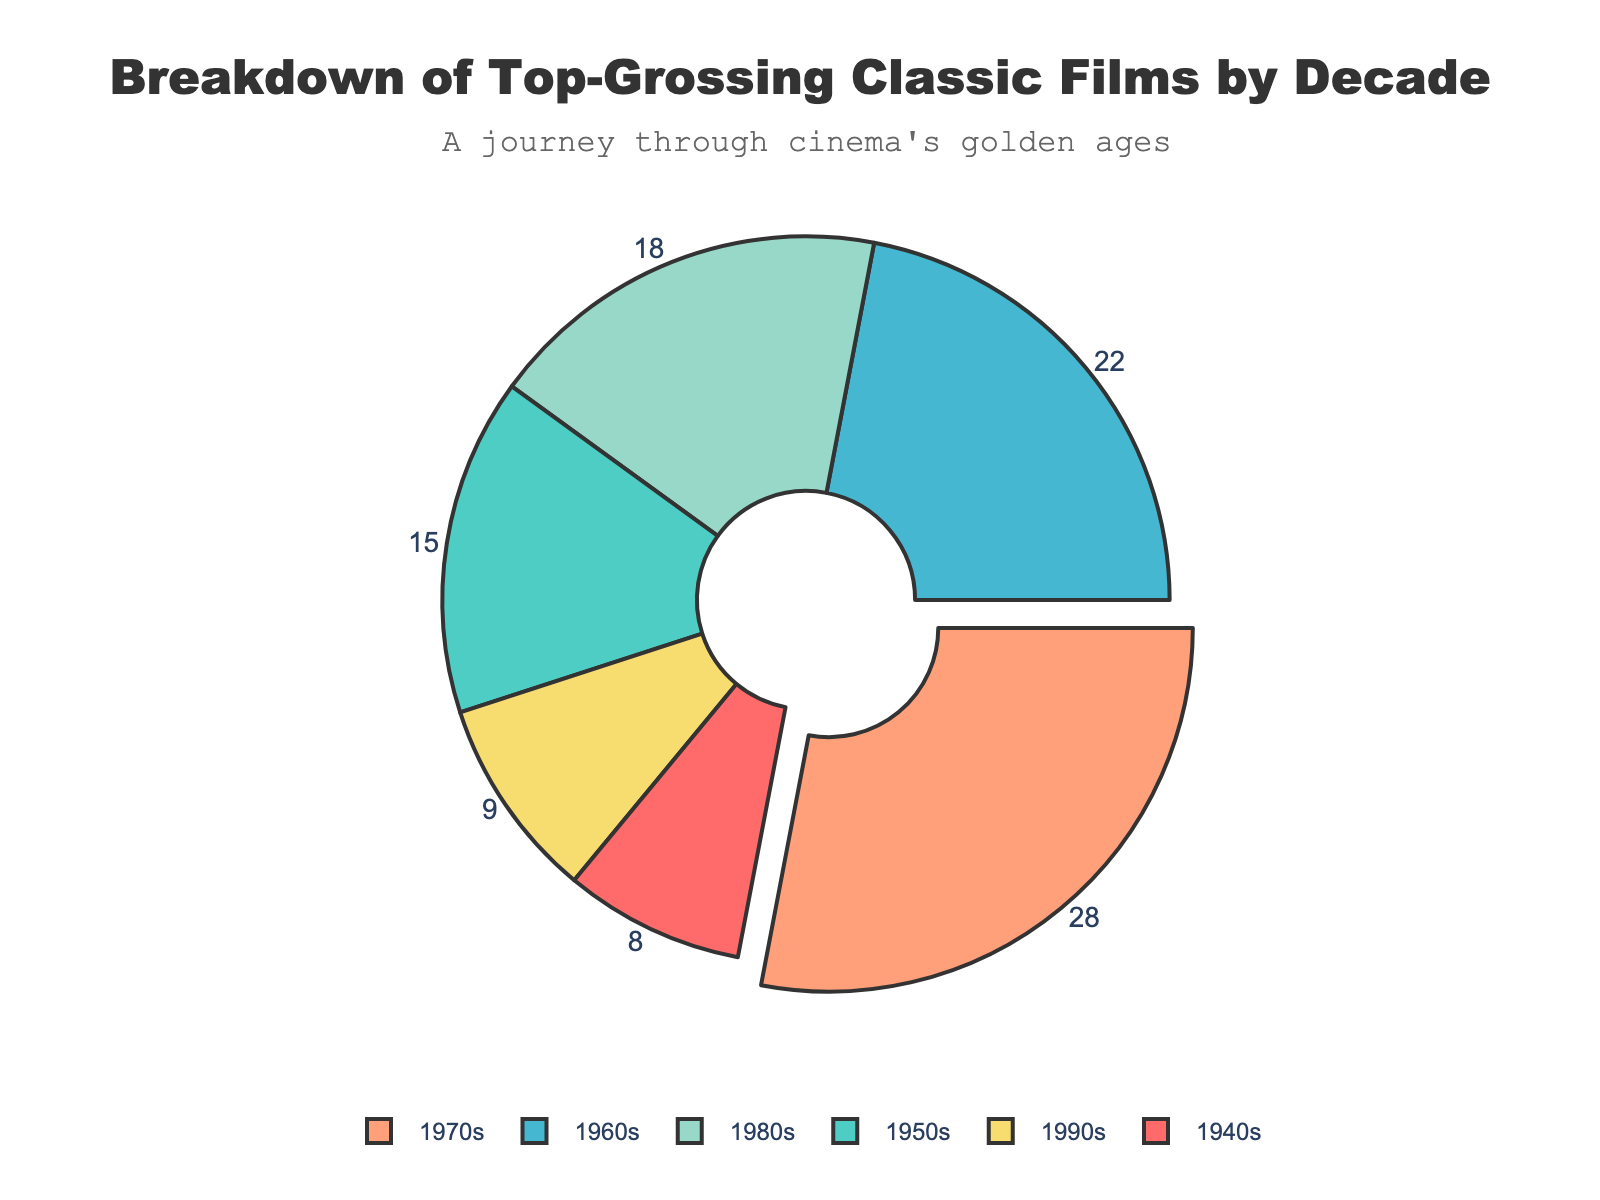Which decade had the highest percentage of top-grossing classic films? By looking at the pie chart, the decade with the largest slice and the label pulled out is the 1970s. This indicates that the 1970s had the highest percentage.
Answer: 1970s Which decades combined have the same percentage as the 1970s? The 1970s have 28%. By adding the percentages of the 1940s (8%) and the 1980s (18%), we get 8% + 18% = 26%. Including the 1940s (8%) and the 1990s (9%), we get 8% + 9% = 17%, so they do not match. Thus, the correct combination is the 1950s (15%) and the 1990s (9%), giving 15% + 9% = 24%, which does not match either. Therefore, no combination of two other decades sums to exactly 28%.
Answer: None Is the proportion of top-grossing films from the 1960s greater than that of the 1980s? By comparing the values directly from the pie chart, the 1960s have 22%, whereas the 1980s have 18%. 22% is greater than 18%.
Answer: Yes How much more significant was the proportion of top-grossing films in the 1970s compared to the 1940s? The percentage for the 1970s is 28%, and for the 1940s, it is 8%. To find the difference: 28% - 8% = 20%.
Answer: 20% What is the average percentage of top-grossing films across the six decades? To calculate the average, add all the percentages together and divide by the number of decades: (8% + 15% + 22% + 28% + 18% + 9%) / 6 = 100% / 6 ≈ 16.67%.
Answer: 16.67% Do any two decades have an equal percentage of top-grossing films? By examining the percentages from the chart, each decade has a distinct percentage: 8%, 15%, 22%, 28%, 18%, and 9%. No two decades share the same percentage.
Answer: No Which decade had the second-lowest proportion of top-grossing films? By arranging the percentages from lowest to highest: 8% (1940s), 9% (1990s), 15% (1950s), 18% (1980s), 22% (1960s), and 28% (1970s), we see that the 1990s have the second-lowest proportion at 9%.
Answer: 1990s By how much does the proportion of top-grossing films from the 1950s exceed the average percentage? First, calculate the average percentage, which is 16.67%. The proportion for the 1950s is 15%. To determine how much it exceeds the average: 15% - 16.67% = -1.67% (it doesn't exceed, but falls short).
Answer: -1.67% What is the total percentage of top-grossing films from the 1960s and 1980s combined? Adding the percentages for the 1960s (22%) and the 1980s (18%): 22% + 18% = 40%.
Answer: 40% Which decade is represented by the green color in the pie chart? The green color represents the 1950s, as each slice is distinctly colored and labeled in the pie chart.
Answer: 1950s 